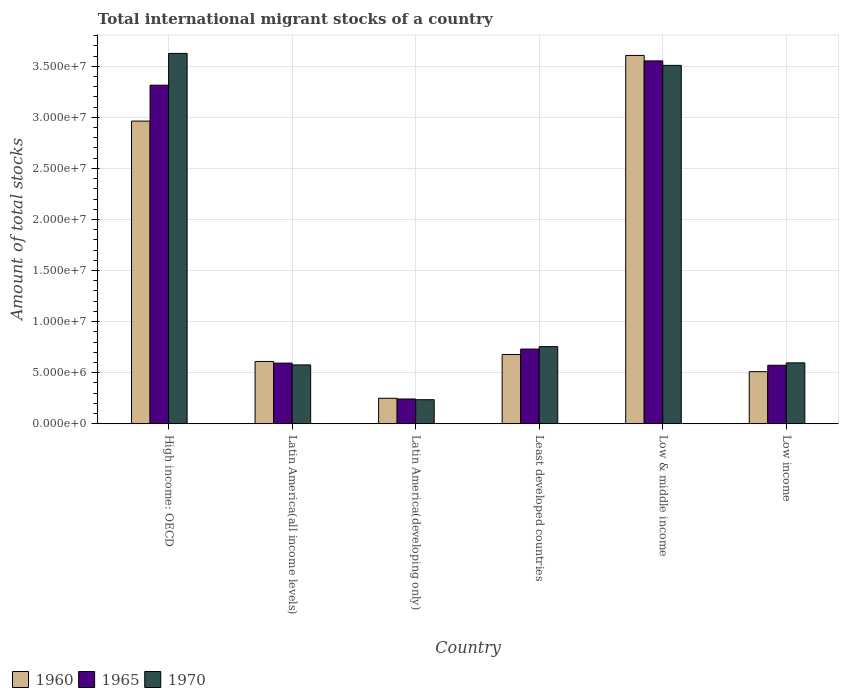How many different coloured bars are there?
Keep it short and to the point. 3. How many groups of bars are there?
Ensure brevity in your answer.  6. How many bars are there on the 1st tick from the right?
Your answer should be compact. 3. What is the label of the 2nd group of bars from the left?
Keep it short and to the point. Latin America(all income levels). In how many cases, is the number of bars for a given country not equal to the number of legend labels?
Offer a terse response. 0. What is the amount of total stocks in in 1960 in Least developed countries?
Your answer should be very brief. 6.78e+06. Across all countries, what is the maximum amount of total stocks in in 1960?
Your answer should be compact. 3.61e+07. Across all countries, what is the minimum amount of total stocks in in 1970?
Your answer should be compact. 2.35e+06. In which country was the amount of total stocks in in 1960 maximum?
Provide a succinct answer. Low & middle income. In which country was the amount of total stocks in in 1970 minimum?
Ensure brevity in your answer.  Latin America(developing only). What is the total amount of total stocks in in 1960 in the graph?
Ensure brevity in your answer.  8.62e+07. What is the difference between the amount of total stocks in in 1970 in Latin America(developing only) and that in Low & middle income?
Provide a short and direct response. -3.27e+07. What is the difference between the amount of total stocks in in 1965 in Latin America(developing only) and the amount of total stocks in in 1960 in Latin America(all income levels)?
Offer a very short reply. -3.67e+06. What is the average amount of total stocks in in 1965 per country?
Provide a succinct answer. 1.50e+07. What is the difference between the amount of total stocks in of/in 1965 and amount of total stocks in of/in 1970 in Latin America(developing only)?
Offer a terse response. 6.84e+04. What is the ratio of the amount of total stocks in in 1965 in Latin America(developing only) to that in Least developed countries?
Give a very brief answer. 0.33. Is the amount of total stocks in in 1960 in Latin America(developing only) less than that in Low & middle income?
Your response must be concise. Yes. Is the difference between the amount of total stocks in in 1965 in Latin America(developing only) and Low & middle income greater than the difference between the amount of total stocks in in 1970 in Latin America(developing only) and Low & middle income?
Your answer should be very brief. No. What is the difference between the highest and the second highest amount of total stocks in in 1965?
Your answer should be very brief. 2.58e+07. What is the difference between the highest and the lowest amount of total stocks in in 1965?
Provide a succinct answer. 3.31e+07. In how many countries, is the amount of total stocks in in 1960 greater than the average amount of total stocks in in 1960 taken over all countries?
Provide a succinct answer. 2. Is the sum of the amount of total stocks in in 1960 in High income: OECD and Low & middle income greater than the maximum amount of total stocks in in 1965 across all countries?
Your answer should be compact. Yes. What does the 1st bar from the left in High income: OECD represents?
Provide a short and direct response. 1960. What does the 3rd bar from the right in High income: OECD represents?
Keep it short and to the point. 1960. Is it the case that in every country, the sum of the amount of total stocks in in 1960 and amount of total stocks in in 1965 is greater than the amount of total stocks in in 1970?
Your answer should be compact. Yes. How many bars are there?
Keep it short and to the point. 18. Are all the bars in the graph horizontal?
Give a very brief answer. No. What is the difference between two consecutive major ticks on the Y-axis?
Your response must be concise. 5.00e+06. Where does the legend appear in the graph?
Keep it short and to the point. Bottom left. What is the title of the graph?
Ensure brevity in your answer.  Total international migrant stocks of a country. What is the label or title of the Y-axis?
Give a very brief answer. Amount of total stocks. What is the Amount of total stocks of 1960 in High income: OECD?
Your response must be concise. 2.96e+07. What is the Amount of total stocks in 1965 in High income: OECD?
Provide a short and direct response. 3.31e+07. What is the Amount of total stocks of 1970 in High income: OECD?
Your response must be concise. 3.63e+07. What is the Amount of total stocks in 1960 in Latin America(all income levels)?
Keep it short and to the point. 6.10e+06. What is the Amount of total stocks of 1965 in Latin America(all income levels)?
Provide a short and direct response. 5.94e+06. What is the Amount of total stocks of 1970 in Latin America(all income levels)?
Your response must be concise. 5.76e+06. What is the Amount of total stocks in 1960 in Latin America(developing only)?
Ensure brevity in your answer.  2.49e+06. What is the Amount of total stocks in 1965 in Latin America(developing only)?
Keep it short and to the point. 2.42e+06. What is the Amount of total stocks of 1970 in Latin America(developing only)?
Ensure brevity in your answer.  2.35e+06. What is the Amount of total stocks of 1960 in Least developed countries?
Give a very brief answer. 6.78e+06. What is the Amount of total stocks of 1965 in Least developed countries?
Your answer should be very brief. 7.31e+06. What is the Amount of total stocks in 1970 in Least developed countries?
Keep it short and to the point. 7.55e+06. What is the Amount of total stocks in 1960 in Low & middle income?
Offer a very short reply. 3.61e+07. What is the Amount of total stocks of 1965 in Low & middle income?
Give a very brief answer. 3.55e+07. What is the Amount of total stocks of 1970 in Low & middle income?
Ensure brevity in your answer.  3.51e+07. What is the Amount of total stocks of 1960 in Low income?
Your response must be concise. 5.10e+06. What is the Amount of total stocks in 1965 in Low income?
Provide a succinct answer. 5.73e+06. What is the Amount of total stocks in 1970 in Low income?
Provide a short and direct response. 5.96e+06. Across all countries, what is the maximum Amount of total stocks in 1960?
Provide a short and direct response. 3.61e+07. Across all countries, what is the maximum Amount of total stocks of 1965?
Offer a terse response. 3.55e+07. Across all countries, what is the maximum Amount of total stocks in 1970?
Your answer should be very brief. 3.63e+07. Across all countries, what is the minimum Amount of total stocks in 1960?
Provide a short and direct response. 2.49e+06. Across all countries, what is the minimum Amount of total stocks of 1965?
Your answer should be compact. 2.42e+06. Across all countries, what is the minimum Amount of total stocks of 1970?
Offer a terse response. 2.35e+06. What is the total Amount of total stocks in 1960 in the graph?
Keep it short and to the point. 8.62e+07. What is the total Amount of total stocks of 1965 in the graph?
Offer a terse response. 9.01e+07. What is the total Amount of total stocks in 1970 in the graph?
Your answer should be very brief. 9.30e+07. What is the difference between the Amount of total stocks of 1960 in High income: OECD and that in Latin America(all income levels)?
Offer a very short reply. 2.35e+07. What is the difference between the Amount of total stocks in 1965 in High income: OECD and that in Latin America(all income levels)?
Your response must be concise. 2.72e+07. What is the difference between the Amount of total stocks in 1970 in High income: OECD and that in Latin America(all income levels)?
Keep it short and to the point. 3.05e+07. What is the difference between the Amount of total stocks in 1960 in High income: OECD and that in Latin America(developing only)?
Ensure brevity in your answer.  2.71e+07. What is the difference between the Amount of total stocks of 1965 in High income: OECD and that in Latin America(developing only)?
Your answer should be compact. 3.07e+07. What is the difference between the Amount of total stocks in 1970 in High income: OECD and that in Latin America(developing only)?
Provide a short and direct response. 3.39e+07. What is the difference between the Amount of total stocks of 1960 in High income: OECD and that in Least developed countries?
Provide a succinct answer. 2.28e+07. What is the difference between the Amount of total stocks of 1965 in High income: OECD and that in Least developed countries?
Offer a terse response. 2.58e+07. What is the difference between the Amount of total stocks of 1970 in High income: OECD and that in Least developed countries?
Provide a short and direct response. 2.87e+07. What is the difference between the Amount of total stocks of 1960 in High income: OECD and that in Low & middle income?
Ensure brevity in your answer.  -6.43e+06. What is the difference between the Amount of total stocks of 1965 in High income: OECD and that in Low & middle income?
Provide a short and direct response. -2.38e+06. What is the difference between the Amount of total stocks in 1970 in High income: OECD and that in Low & middle income?
Offer a very short reply. 1.17e+06. What is the difference between the Amount of total stocks in 1960 in High income: OECD and that in Low income?
Give a very brief answer. 2.45e+07. What is the difference between the Amount of total stocks in 1965 in High income: OECD and that in Low income?
Your answer should be very brief. 2.74e+07. What is the difference between the Amount of total stocks of 1970 in High income: OECD and that in Low income?
Your answer should be very brief. 3.03e+07. What is the difference between the Amount of total stocks in 1960 in Latin America(all income levels) and that in Latin America(developing only)?
Offer a terse response. 3.60e+06. What is the difference between the Amount of total stocks in 1965 in Latin America(all income levels) and that in Latin America(developing only)?
Offer a terse response. 3.51e+06. What is the difference between the Amount of total stocks of 1970 in Latin America(all income levels) and that in Latin America(developing only)?
Make the answer very short. 3.41e+06. What is the difference between the Amount of total stocks of 1960 in Latin America(all income levels) and that in Least developed countries?
Give a very brief answer. -6.86e+05. What is the difference between the Amount of total stocks in 1965 in Latin America(all income levels) and that in Least developed countries?
Give a very brief answer. -1.37e+06. What is the difference between the Amount of total stocks in 1970 in Latin America(all income levels) and that in Least developed countries?
Offer a terse response. -1.79e+06. What is the difference between the Amount of total stocks of 1960 in Latin America(all income levels) and that in Low & middle income?
Your answer should be very brief. -3.00e+07. What is the difference between the Amount of total stocks of 1965 in Latin America(all income levels) and that in Low & middle income?
Make the answer very short. -2.96e+07. What is the difference between the Amount of total stocks of 1970 in Latin America(all income levels) and that in Low & middle income?
Your answer should be compact. -2.93e+07. What is the difference between the Amount of total stocks in 1960 in Latin America(all income levels) and that in Low income?
Make the answer very short. 9.99e+05. What is the difference between the Amount of total stocks in 1965 in Latin America(all income levels) and that in Low income?
Your answer should be compact. 2.09e+05. What is the difference between the Amount of total stocks in 1970 in Latin America(all income levels) and that in Low income?
Your answer should be compact. -2.01e+05. What is the difference between the Amount of total stocks of 1960 in Latin America(developing only) and that in Least developed countries?
Give a very brief answer. -4.29e+06. What is the difference between the Amount of total stocks in 1965 in Latin America(developing only) and that in Least developed countries?
Your response must be concise. -4.89e+06. What is the difference between the Amount of total stocks in 1970 in Latin America(developing only) and that in Least developed countries?
Offer a very short reply. -5.20e+06. What is the difference between the Amount of total stocks of 1960 in Latin America(developing only) and that in Low & middle income?
Offer a terse response. -3.36e+07. What is the difference between the Amount of total stocks in 1965 in Latin America(developing only) and that in Low & middle income?
Provide a succinct answer. -3.31e+07. What is the difference between the Amount of total stocks in 1970 in Latin America(developing only) and that in Low & middle income?
Offer a very short reply. -3.27e+07. What is the difference between the Amount of total stocks in 1960 in Latin America(developing only) and that in Low income?
Offer a terse response. -2.60e+06. What is the difference between the Amount of total stocks of 1965 in Latin America(developing only) and that in Low income?
Offer a terse response. -3.31e+06. What is the difference between the Amount of total stocks in 1970 in Latin America(developing only) and that in Low income?
Offer a very short reply. -3.61e+06. What is the difference between the Amount of total stocks in 1960 in Least developed countries and that in Low & middle income?
Ensure brevity in your answer.  -2.93e+07. What is the difference between the Amount of total stocks of 1965 in Least developed countries and that in Low & middle income?
Provide a succinct answer. -2.82e+07. What is the difference between the Amount of total stocks in 1970 in Least developed countries and that in Low & middle income?
Your answer should be compact. -2.75e+07. What is the difference between the Amount of total stocks in 1960 in Least developed countries and that in Low income?
Your answer should be compact. 1.69e+06. What is the difference between the Amount of total stocks of 1965 in Least developed countries and that in Low income?
Make the answer very short. 1.58e+06. What is the difference between the Amount of total stocks of 1970 in Least developed countries and that in Low income?
Your answer should be very brief. 1.59e+06. What is the difference between the Amount of total stocks of 1960 in Low & middle income and that in Low income?
Offer a terse response. 3.10e+07. What is the difference between the Amount of total stocks of 1965 in Low & middle income and that in Low income?
Give a very brief answer. 2.98e+07. What is the difference between the Amount of total stocks of 1970 in Low & middle income and that in Low income?
Ensure brevity in your answer.  2.91e+07. What is the difference between the Amount of total stocks in 1960 in High income: OECD and the Amount of total stocks in 1965 in Latin America(all income levels)?
Ensure brevity in your answer.  2.37e+07. What is the difference between the Amount of total stocks in 1960 in High income: OECD and the Amount of total stocks in 1970 in Latin America(all income levels)?
Your answer should be compact. 2.39e+07. What is the difference between the Amount of total stocks in 1965 in High income: OECD and the Amount of total stocks in 1970 in Latin America(all income levels)?
Keep it short and to the point. 2.74e+07. What is the difference between the Amount of total stocks of 1960 in High income: OECD and the Amount of total stocks of 1965 in Latin America(developing only)?
Give a very brief answer. 2.72e+07. What is the difference between the Amount of total stocks in 1960 in High income: OECD and the Amount of total stocks in 1970 in Latin America(developing only)?
Your response must be concise. 2.73e+07. What is the difference between the Amount of total stocks in 1965 in High income: OECD and the Amount of total stocks in 1970 in Latin America(developing only)?
Offer a terse response. 3.08e+07. What is the difference between the Amount of total stocks in 1960 in High income: OECD and the Amount of total stocks in 1965 in Least developed countries?
Ensure brevity in your answer.  2.23e+07. What is the difference between the Amount of total stocks of 1960 in High income: OECD and the Amount of total stocks of 1970 in Least developed countries?
Your answer should be compact. 2.21e+07. What is the difference between the Amount of total stocks of 1965 in High income: OECD and the Amount of total stocks of 1970 in Least developed countries?
Your answer should be compact. 2.56e+07. What is the difference between the Amount of total stocks in 1960 in High income: OECD and the Amount of total stocks in 1965 in Low & middle income?
Provide a short and direct response. -5.89e+06. What is the difference between the Amount of total stocks in 1960 in High income: OECD and the Amount of total stocks in 1970 in Low & middle income?
Offer a terse response. -5.46e+06. What is the difference between the Amount of total stocks in 1965 in High income: OECD and the Amount of total stocks in 1970 in Low & middle income?
Your answer should be compact. -1.94e+06. What is the difference between the Amount of total stocks in 1960 in High income: OECD and the Amount of total stocks in 1965 in Low income?
Provide a succinct answer. 2.39e+07. What is the difference between the Amount of total stocks in 1960 in High income: OECD and the Amount of total stocks in 1970 in Low income?
Your answer should be very brief. 2.37e+07. What is the difference between the Amount of total stocks in 1965 in High income: OECD and the Amount of total stocks in 1970 in Low income?
Your answer should be compact. 2.72e+07. What is the difference between the Amount of total stocks of 1960 in Latin America(all income levels) and the Amount of total stocks of 1965 in Latin America(developing only)?
Your answer should be very brief. 3.67e+06. What is the difference between the Amount of total stocks in 1960 in Latin America(all income levels) and the Amount of total stocks in 1970 in Latin America(developing only)?
Ensure brevity in your answer.  3.74e+06. What is the difference between the Amount of total stocks of 1965 in Latin America(all income levels) and the Amount of total stocks of 1970 in Latin America(developing only)?
Keep it short and to the point. 3.58e+06. What is the difference between the Amount of total stocks of 1960 in Latin America(all income levels) and the Amount of total stocks of 1965 in Least developed countries?
Make the answer very short. -1.21e+06. What is the difference between the Amount of total stocks of 1960 in Latin America(all income levels) and the Amount of total stocks of 1970 in Least developed countries?
Your response must be concise. -1.45e+06. What is the difference between the Amount of total stocks of 1965 in Latin America(all income levels) and the Amount of total stocks of 1970 in Least developed countries?
Provide a short and direct response. -1.61e+06. What is the difference between the Amount of total stocks in 1960 in Latin America(all income levels) and the Amount of total stocks in 1965 in Low & middle income?
Your response must be concise. -2.94e+07. What is the difference between the Amount of total stocks in 1960 in Latin America(all income levels) and the Amount of total stocks in 1970 in Low & middle income?
Offer a terse response. -2.90e+07. What is the difference between the Amount of total stocks in 1965 in Latin America(all income levels) and the Amount of total stocks in 1970 in Low & middle income?
Your answer should be compact. -2.92e+07. What is the difference between the Amount of total stocks of 1960 in Latin America(all income levels) and the Amount of total stocks of 1965 in Low income?
Give a very brief answer. 3.69e+05. What is the difference between the Amount of total stocks in 1960 in Latin America(all income levels) and the Amount of total stocks in 1970 in Low income?
Provide a short and direct response. 1.36e+05. What is the difference between the Amount of total stocks in 1965 in Latin America(all income levels) and the Amount of total stocks in 1970 in Low income?
Provide a succinct answer. -2.38e+04. What is the difference between the Amount of total stocks of 1960 in Latin America(developing only) and the Amount of total stocks of 1965 in Least developed countries?
Provide a short and direct response. -4.82e+06. What is the difference between the Amount of total stocks of 1960 in Latin America(developing only) and the Amount of total stocks of 1970 in Least developed countries?
Offer a very short reply. -5.06e+06. What is the difference between the Amount of total stocks of 1965 in Latin America(developing only) and the Amount of total stocks of 1970 in Least developed countries?
Keep it short and to the point. -5.13e+06. What is the difference between the Amount of total stocks in 1960 in Latin America(developing only) and the Amount of total stocks in 1965 in Low & middle income?
Give a very brief answer. -3.30e+07. What is the difference between the Amount of total stocks in 1960 in Latin America(developing only) and the Amount of total stocks in 1970 in Low & middle income?
Give a very brief answer. -3.26e+07. What is the difference between the Amount of total stocks of 1965 in Latin America(developing only) and the Amount of total stocks of 1970 in Low & middle income?
Give a very brief answer. -3.27e+07. What is the difference between the Amount of total stocks in 1960 in Latin America(developing only) and the Amount of total stocks in 1965 in Low income?
Ensure brevity in your answer.  -3.23e+06. What is the difference between the Amount of total stocks in 1960 in Latin America(developing only) and the Amount of total stocks in 1970 in Low income?
Provide a succinct answer. -3.47e+06. What is the difference between the Amount of total stocks of 1965 in Latin America(developing only) and the Amount of total stocks of 1970 in Low income?
Your answer should be very brief. -3.54e+06. What is the difference between the Amount of total stocks of 1960 in Least developed countries and the Amount of total stocks of 1965 in Low & middle income?
Provide a succinct answer. -2.87e+07. What is the difference between the Amount of total stocks in 1960 in Least developed countries and the Amount of total stocks in 1970 in Low & middle income?
Keep it short and to the point. -2.83e+07. What is the difference between the Amount of total stocks in 1965 in Least developed countries and the Amount of total stocks in 1970 in Low & middle income?
Your answer should be compact. -2.78e+07. What is the difference between the Amount of total stocks of 1960 in Least developed countries and the Amount of total stocks of 1965 in Low income?
Offer a terse response. 1.06e+06. What is the difference between the Amount of total stocks of 1960 in Least developed countries and the Amount of total stocks of 1970 in Low income?
Give a very brief answer. 8.22e+05. What is the difference between the Amount of total stocks in 1965 in Least developed countries and the Amount of total stocks in 1970 in Low income?
Your response must be concise. 1.35e+06. What is the difference between the Amount of total stocks in 1960 in Low & middle income and the Amount of total stocks in 1965 in Low income?
Provide a succinct answer. 3.03e+07. What is the difference between the Amount of total stocks in 1960 in Low & middle income and the Amount of total stocks in 1970 in Low income?
Your answer should be very brief. 3.01e+07. What is the difference between the Amount of total stocks in 1965 in Low & middle income and the Amount of total stocks in 1970 in Low income?
Your answer should be compact. 2.96e+07. What is the average Amount of total stocks of 1960 per country?
Your answer should be very brief. 1.44e+07. What is the average Amount of total stocks of 1965 per country?
Keep it short and to the point. 1.50e+07. What is the average Amount of total stocks in 1970 per country?
Provide a succinct answer. 1.55e+07. What is the difference between the Amount of total stocks in 1960 and Amount of total stocks in 1965 in High income: OECD?
Your response must be concise. -3.52e+06. What is the difference between the Amount of total stocks in 1960 and Amount of total stocks in 1970 in High income: OECD?
Provide a short and direct response. -6.63e+06. What is the difference between the Amount of total stocks of 1965 and Amount of total stocks of 1970 in High income: OECD?
Ensure brevity in your answer.  -3.11e+06. What is the difference between the Amount of total stocks of 1960 and Amount of total stocks of 1965 in Latin America(all income levels)?
Offer a very short reply. 1.60e+05. What is the difference between the Amount of total stocks of 1960 and Amount of total stocks of 1970 in Latin America(all income levels)?
Your answer should be compact. 3.37e+05. What is the difference between the Amount of total stocks in 1965 and Amount of total stocks in 1970 in Latin America(all income levels)?
Provide a short and direct response. 1.77e+05. What is the difference between the Amount of total stocks in 1960 and Amount of total stocks in 1965 in Latin America(developing only)?
Keep it short and to the point. 7.11e+04. What is the difference between the Amount of total stocks in 1960 and Amount of total stocks in 1970 in Latin America(developing only)?
Make the answer very short. 1.39e+05. What is the difference between the Amount of total stocks of 1965 and Amount of total stocks of 1970 in Latin America(developing only)?
Keep it short and to the point. 6.84e+04. What is the difference between the Amount of total stocks of 1960 and Amount of total stocks of 1965 in Least developed countries?
Your answer should be very brief. -5.28e+05. What is the difference between the Amount of total stocks of 1960 and Amount of total stocks of 1970 in Least developed countries?
Provide a short and direct response. -7.68e+05. What is the difference between the Amount of total stocks of 1965 and Amount of total stocks of 1970 in Least developed countries?
Give a very brief answer. -2.40e+05. What is the difference between the Amount of total stocks in 1960 and Amount of total stocks in 1965 in Low & middle income?
Your response must be concise. 5.35e+05. What is the difference between the Amount of total stocks of 1960 and Amount of total stocks of 1970 in Low & middle income?
Give a very brief answer. 9.73e+05. What is the difference between the Amount of total stocks in 1965 and Amount of total stocks in 1970 in Low & middle income?
Provide a short and direct response. 4.38e+05. What is the difference between the Amount of total stocks of 1960 and Amount of total stocks of 1965 in Low income?
Give a very brief answer. -6.30e+05. What is the difference between the Amount of total stocks in 1960 and Amount of total stocks in 1970 in Low income?
Your answer should be very brief. -8.63e+05. What is the difference between the Amount of total stocks in 1965 and Amount of total stocks in 1970 in Low income?
Your response must be concise. -2.33e+05. What is the ratio of the Amount of total stocks in 1960 in High income: OECD to that in Latin America(all income levels)?
Make the answer very short. 4.86. What is the ratio of the Amount of total stocks of 1965 in High income: OECD to that in Latin America(all income levels)?
Provide a short and direct response. 5.58. What is the ratio of the Amount of total stocks of 1970 in High income: OECD to that in Latin America(all income levels)?
Offer a very short reply. 6.3. What is the ratio of the Amount of total stocks in 1960 in High income: OECD to that in Latin America(developing only)?
Ensure brevity in your answer.  11.88. What is the ratio of the Amount of total stocks of 1965 in High income: OECD to that in Latin America(developing only)?
Make the answer very short. 13.68. What is the ratio of the Amount of total stocks of 1970 in High income: OECD to that in Latin America(developing only)?
Keep it short and to the point. 15.4. What is the ratio of the Amount of total stocks in 1960 in High income: OECD to that in Least developed countries?
Provide a succinct answer. 4.37. What is the ratio of the Amount of total stocks of 1965 in High income: OECD to that in Least developed countries?
Your response must be concise. 4.53. What is the ratio of the Amount of total stocks in 1970 in High income: OECD to that in Least developed countries?
Your response must be concise. 4.8. What is the ratio of the Amount of total stocks of 1960 in High income: OECD to that in Low & middle income?
Your answer should be compact. 0.82. What is the ratio of the Amount of total stocks of 1965 in High income: OECD to that in Low & middle income?
Make the answer very short. 0.93. What is the ratio of the Amount of total stocks of 1970 in High income: OECD to that in Low & middle income?
Make the answer very short. 1.03. What is the ratio of the Amount of total stocks of 1960 in High income: OECD to that in Low income?
Give a very brief answer. 5.81. What is the ratio of the Amount of total stocks of 1965 in High income: OECD to that in Low income?
Offer a very short reply. 5.79. What is the ratio of the Amount of total stocks in 1970 in High income: OECD to that in Low income?
Give a very brief answer. 6.08. What is the ratio of the Amount of total stocks in 1960 in Latin America(all income levels) to that in Latin America(developing only)?
Keep it short and to the point. 2.44. What is the ratio of the Amount of total stocks of 1965 in Latin America(all income levels) to that in Latin America(developing only)?
Provide a short and direct response. 2.45. What is the ratio of the Amount of total stocks in 1970 in Latin America(all income levels) to that in Latin America(developing only)?
Give a very brief answer. 2.45. What is the ratio of the Amount of total stocks of 1960 in Latin America(all income levels) to that in Least developed countries?
Your answer should be compact. 0.9. What is the ratio of the Amount of total stocks of 1965 in Latin America(all income levels) to that in Least developed countries?
Make the answer very short. 0.81. What is the ratio of the Amount of total stocks in 1970 in Latin America(all income levels) to that in Least developed countries?
Your answer should be very brief. 0.76. What is the ratio of the Amount of total stocks of 1960 in Latin America(all income levels) to that in Low & middle income?
Offer a very short reply. 0.17. What is the ratio of the Amount of total stocks in 1965 in Latin America(all income levels) to that in Low & middle income?
Make the answer very short. 0.17. What is the ratio of the Amount of total stocks in 1970 in Latin America(all income levels) to that in Low & middle income?
Ensure brevity in your answer.  0.16. What is the ratio of the Amount of total stocks of 1960 in Latin America(all income levels) to that in Low income?
Keep it short and to the point. 1.2. What is the ratio of the Amount of total stocks in 1965 in Latin America(all income levels) to that in Low income?
Provide a succinct answer. 1.04. What is the ratio of the Amount of total stocks in 1970 in Latin America(all income levels) to that in Low income?
Ensure brevity in your answer.  0.97. What is the ratio of the Amount of total stocks in 1960 in Latin America(developing only) to that in Least developed countries?
Your answer should be very brief. 0.37. What is the ratio of the Amount of total stocks in 1965 in Latin America(developing only) to that in Least developed countries?
Provide a succinct answer. 0.33. What is the ratio of the Amount of total stocks of 1970 in Latin America(developing only) to that in Least developed countries?
Offer a terse response. 0.31. What is the ratio of the Amount of total stocks in 1960 in Latin America(developing only) to that in Low & middle income?
Provide a succinct answer. 0.07. What is the ratio of the Amount of total stocks of 1965 in Latin America(developing only) to that in Low & middle income?
Ensure brevity in your answer.  0.07. What is the ratio of the Amount of total stocks of 1970 in Latin America(developing only) to that in Low & middle income?
Ensure brevity in your answer.  0.07. What is the ratio of the Amount of total stocks of 1960 in Latin America(developing only) to that in Low income?
Your response must be concise. 0.49. What is the ratio of the Amount of total stocks of 1965 in Latin America(developing only) to that in Low income?
Your answer should be compact. 0.42. What is the ratio of the Amount of total stocks in 1970 in Latin America(developing only) to that in Low income?
Your response must be concise. 0.39. What is the ratio of the Amount of total stocks of 1960 in Least developed countries to that in Low & middle income?
Keep it short and to the point. 0.19. What is the ratio of the Amount of total stocks in 1965 in Least developed countries to that in Low & middle income?
Offer a terse response. 0.21. What is the ratio of the Amount of total stocks of 1970 in Least developed countries to that in Low & middle income?
Provide a succinct answer. 0.22. What is the ratio of the Amount of total stocks of 1960 in Least developed countries to that in Low income?
Ensure brevity in your answer.  1.33. What is the ratio of the Amount of total stocks of 1965 in Least developed countries to that in Low income?
Offer a very short reply. 1.28. What is the ratio of the Amount of total stocks in 1970 in Least developed countries to that in Low income?
Offer a very short reply. 1.27. What is the ratio of the Amount of total stocks of 1960 in Low & middle income to that in Low income?
Provide a short and direct response. 7.07. What is the ratio of the Amount of total stocks in 1965 in Low & middle income to that in Low income?
Your response must be concise. 6.2. What is the ratio of the Amount of total stocks of 1970 in Low & middle income to that in Low income?
Give a very brief answer. 5.89. What is the difference between the highest and the second highest Amount of total stocks in 1960?
Your answer should be very brief. 6.43e+06. What is the difference between the highest and the second highest Amount of total stocks of 1965?
Your answer should be very brief. 2.38e+06. What is the difference between the highest and the second highest Amount of total stocks of 1970?
Your answer should be compact. 1.17e+06. What is the difference between the highest and the lowest Amount of total stocks of 1960?
Your answer should be very brief. 3.36e+07. What is the difference between the highest and the lowest Amount of total stocks of 1965?
Your answer should be compact. 3.31e+07. What is the difference between the highest and the lowest Amount of total stocks of 1970?
Your response must be concise. 3.39e+07. 